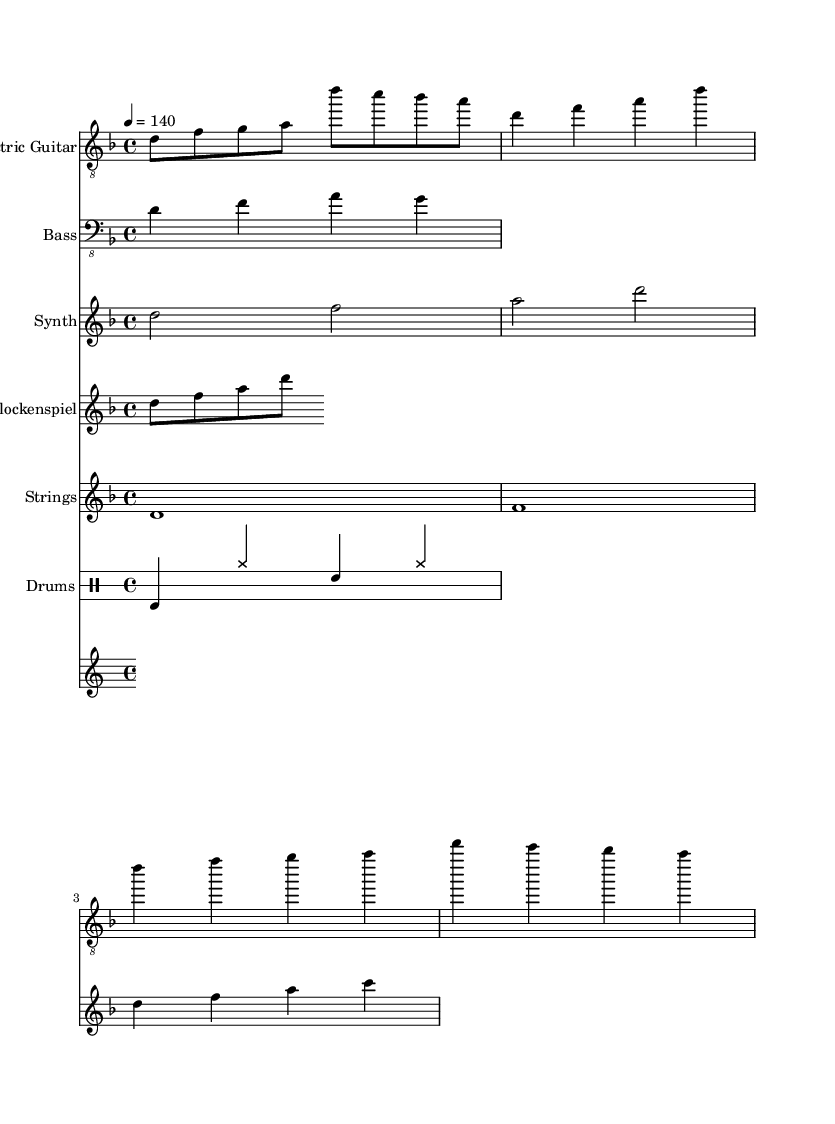What is the key signature of this music? The key signature is D minor, which includes one flat (B flat). This can be observed in the key signature marking at the start of the staff.
Answer: D minor What is the time signature of this music? The time signature is 4/4, represented as a fraction at the beginning of the score. This indicates that there are four beats in each measure and a quarter note gets one beat.
Answer: 4/4 What is the tempo marking in this piece? The tempo marking is indicated as "4 = 140," meaning the quarter note has a tempo of 140 beats per minute. This refers to the speed of the piece, which is indicated at the beginning of the score.
Answer: 140 How many measures are in the electric guitar part? By counting the distinct groupings of notes separated by bar lines in the electric guitar staff, we can see there are 6 measures. This shows the structure of the riffs and sections in the electric guitar part.
Answer: 6 Which instrument plays a glockenspiel part? The sheet clearly indicates the "Glockenspiel" staff at the top of the corresponding section, showing that this instrument contributes to the music's overall soundscape, especially in cinematic style.
Answer: Glockenspiel What type of rhythm is primarily used in the drums section? The drums section consists mainly of a basic rock beat rhythm, which typically includes bass, hi-hat, and snare in a straightforward alternating pattern that is common in metal music.
Answer: Rock beat What is unique about the synth part compared to traditional metal? The synth part features extended note durations (half notes) creating a sustained sound, which is typical for cinematic soundscapes, contrasting with the short, aggressive rhythms often found in traditional metal music.
Answer: Cinematic soundscapes 